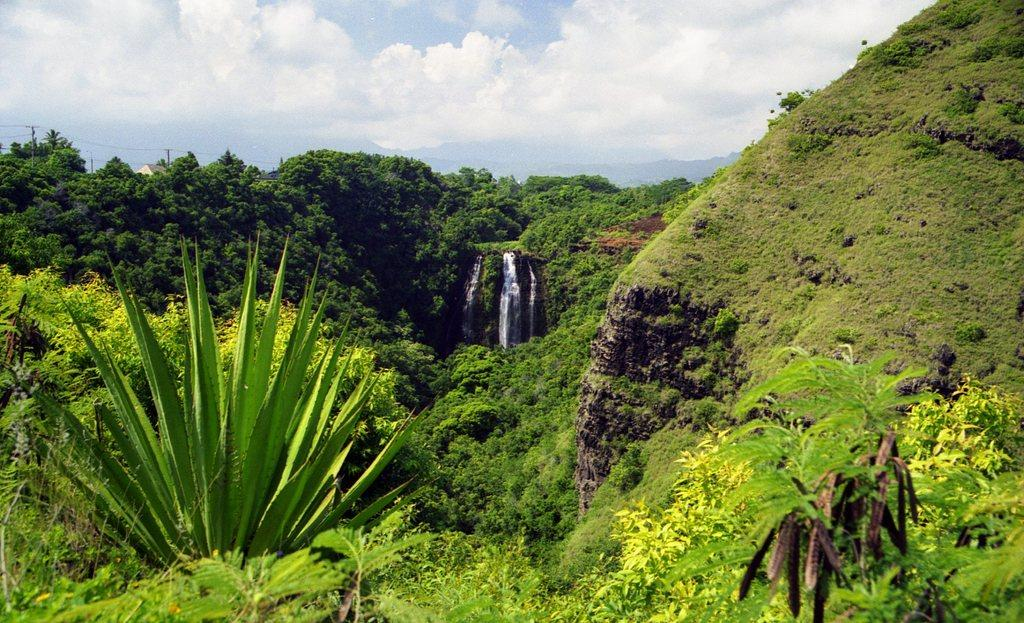What type of vegetation can be seen in the image? There are many plants and trees in the image. What natural feature is present in the image? There is a water flow in the image. What geographical feature is visible in the distance? There are mountains visible in the image. What can be seen in the background of the image? There are clouds and the sky visible in the background of the image. How many boys are playing in the picture? There is no picture or boys present in the image; it features plants, trees, water flow, mountains, clouds, and the sky. What type of friction can be observed between the clouds and the sky in the image? There is no friction between the clouds and the sky in the image; they are simply visible in the background. 